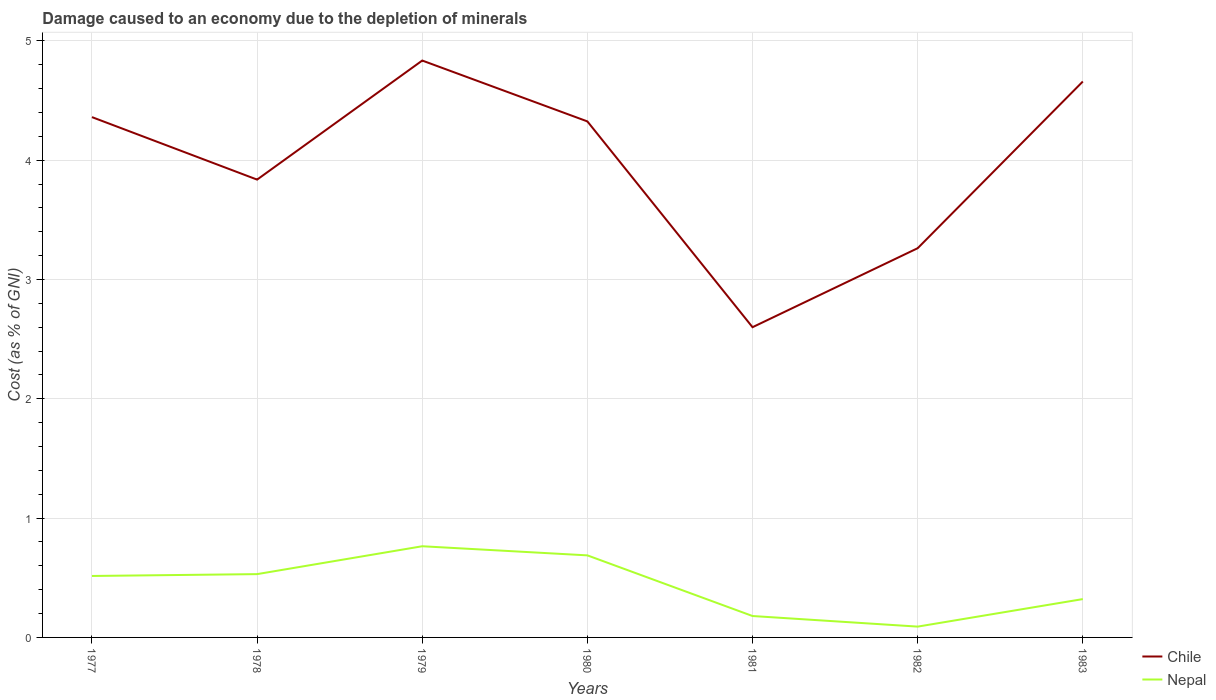How many different coloured lines are there?
Keep it short and to the point. 2. Is the number of lines equal to the number of legend labels?
Keep it short and to the point. Yes. Across all years, what is the maximum cost of damage caused due to the depletion of minerals in Chile?
Provide a short and direct response. 2.6. What is the total cost of damage caused due to the depletion of minerals in Nepal in the graph?
Ensure brevity in your answer.  -0.16. What is the difference between the highest and the second highest cost of damage caused due to the depletion of minerals in Nepal?
Your answer should be compact. 0.67. How many lines are there?
Keep it short and to the point. 2. What is the difference between two consecutive major ticks on the Y-axis?
Offer a terse response. 1. Are the values on the major ticks of Y-axis written in scientific E-notation?
Give a very brief answer. No. Where does the legend appear in the graph?
Keep it short and to the point. Bottom right. How many legend labels are there?
Offer a very short reply. 2. How are the legend labels stacked?
Offer a very short reply. Vertical. What is the title of the graph?
Offer a terse response. Damage caused to an economy due to the depletion of minerals. Does "Eritrea" appear as one of the legend labels in the graph?
Offer a very short reply. No. What is the label or title of the Y-axis?
Give a very brief answer. Cost (as % of GNI). What is the Cost (as % of GNI) of Chile in 1977?
Your response must be concise. 4.36. What is the Cost (as % of GNI) of Nepal in 1977?
Your answer should be compact. 0.52. What is the Cost (as % of GNI) of Chile in 1978?
Your answer should be very brief. 3.84. What is the Cost (as % of GNI) in Nepal in 1978?
Make the answer very short. 0.53. What is the Cost (as % of GNI) of Chile in 1979?
Keep it short and to the point. 4.83. What is the Cost (as % of GNI) in Nepal in 1979?
Offer a terse response. 0.76. What is the Cost (as % of GNI) of Chile in 1980?
Give a very brief answer. 4.32. What is the Cost (as % of GNI) in Nepal in 1980?
Provide a succinct answer. 0.69. What is the Cost (as % of GNI) in Chile in 1981?
Ensure brevity in your answer.  2.6. What is the Cost (as % of GNI) of Nepal in 1981?
Your answer should be compact. 0.18. What is the Cost (as % of GNI) in Chile in 1982?
Your answer should be very brief. 3.26. What is the Cost (as % of GNI) in Nepal in 1982?
Give a very brief answer. 0.09. What is the Cost (as % of GNI) in Chile in 1983?
Offer a very short reply. 4.66. What is the Cost (as % of GNI) of Nepal in 1983?
Offer a very short reply. 0.32. Across all years, what is the maximum Cost (as % of GNI) of Chile?
Offer a terse response. 4.83. Across all years, what is the maximum Cost (as % of GNI) of Nepal?
Your answer should be compact. 0.76. Across all years, what is the minimum Cost (as % of GNI) in Chile?
Your answer should be compact. 2.6. Across all years, what is the minimum Cost (as % of GNI) in Nepal?
Ensure brevity in your answer.  0.09. What is the total Cost (as % of GNI) of Chile in the graph?
Provide a succinct answer. 27.88. What is the total Cost (as % of GNI) in Nepal in the graph?
Keep it short and to the point. 3.09. What is the difference between the Cost (as % of GNI) of Chile in 1977 and that in 1978?
Your answer should be compact. 0.52. What is the difference between the Cost (as % of GNI) in Nepal in 1977 and that in 1978?
Give a very brief answer. -0.02. What is the difference between the Cost (as % of GNI) in Chile in 1977 and that in 1979?
Offer a terse response. -0.47. What is the difference between the Cost (as % of GNI) of Nepal in 1977 and that in 1979?
Your answer should be compact. -0.25. What is the difference between the Cost (as % of GNI) in Chile in 1977 and that in 1980?
Provide a short and direct response. 0.04. What is the difference between the Cost (as % of GNI) in Nepal in 1977 and that in 1980?
Your answer should be very brief. -0.17. What is the difference between the Cost (as % of GNI) in Chile in 1977 and that in 1981?
Keep it short and to the point. 1.76. What is the difference between the Cost (as % of GNI) of Nepal in 1977 and that in 1981?
Your response must be concise. 0.34. What is the difference between the Cost (as % of GNI) of Chile in 1977 and that in 1982?
Ensure brevity in your answer.  1.1. What is the difference between the Cost (as % of GNI) of Nepal in 1977 and that in 1982?
Make the answer very short. 0.42. What is the difference between the Cost (as % of GNI) in Chile in 1977 and that in 1983?
Your answer should be compact. -0.3. What is the difference between the Cost (as % of GNI) in Nepal in 1977 and that in 1983?
Your answer should be very brief. 0.19. What is the difference between the Cost (as % of GNI) in Chile in 1978 and that in 1979?
Offer a very short reply. -1. What is the difference between the Cost (as % of GNI) of Nepal in 1978 and that in 1979?
Ensure brevity in your answer.  -0.23. What is the difference between the Cost (as % of GNI) in Chile in 1978 and that in 1980?
Provide a short and direct response. -0.49. What is the difference between the Cost (as % of GNI) of Nepal in 1978 and that in 1980?
Provide a short and direct response. -0.16. What is the difference between the Cost (as % of GNI) in Chile in 1978 and that in 1981?
Make the answer very short. 1.24. What is the difference between the Cost (as % of GNI) of Nepal in 1978 and that in 1981?
Give a very brief answer. 0.35. What is the difference between the Cost (as % of GNI) of Chile in 1978 and that in 1982?
Ensure brevity in your answer.  0.57. What is the difference between the Cost (as % of GNI) of Nepal in 1978 and that in 1982?
Ensure brevity in your answer.  0.44. What is the difference between the Cost (as % of GNI) in Chile in 1978 and that in 1983?
Make the answer very short. -0.82. What is the difference between the Cost (as % of GNI) of Nepal in 1978 and that in 1983?
Ensure brevity in your answer.  0.21. What is the difference between the Cost (as % of GNI) of Chile in 1979 and that in 1980?
Give a very brief answer. 0.51. What is the difference between the Cost (as % of GNI) of Nepal in 1979 and that in 1980?
Keep it short and to the point. 0.08. What is the difference between the Cost (as % of GNI) in Chile in 1979 and that in 1981?
Provide a succinct answer. 2.23. What is the difference between the Cost (as % of GNI) in Nepal in 1979 and that in 1981?
Offer a very short reply. 0.58. What is the difference between the Cost (as % of GNI) of Chile in 1979 and that in 1982?
Your response must be concise. 1.57. What is the difference between the Cost (as % of GNI) in Nepal in 1979 and that in 1982?
Ensure brevity in your answer.  0.67. What is the difference between the Cost (as % of GNI) in Chile in 1979 and that in 1983?
Offer a very short reply. 0.18. What is the difference between the Cost (as % of GNI) in Nepal in 1979 and that in 1983?
Give a very brief answer. 0.44. What is the difference between the Cost (as % of GNI) of Chile in 1980 and that in 1981?
Give a very brief answer. 1.72. What is the difference between the Cost (as % of GNI) in Nepal in 1980 and that in 1981?
Give a very brief answer. 0.51. What is the difference between the Cost (as % of GNI) of Chile in 1980 and that in 1982?
Offer a terse response. 1.06. What is the difference between the Cost (as % of GNI) of Nepal in 1980 and that in 1982?
Provide a short and direct response. 0.6. What is the difference between the Cost (as % of GNI) in Chile in 1980 and that in 1983?
Give a very brief answer. -0.33. What is the difference between the Cost (as % of GNI) in Nepal in 1980 and that in 1983?
Ensure brevity in your answer.  0.37. What is the difference between the Cost (as % of GNI) in Chile in 1981 and that in 1982?
Provide a short and direct response. -0.66. What is the difference between the Cost (as % of GNI) of Nepal in 1981 and that in 1982?
Provide a succinct answer. 0.09. What is the difference between the Cost (as % of GNI) of Chile in 1981 and that in 1983?
Offer a terse response. -2.06. What is the difference between the Cost (as % of GNI) of Nepal in 1981 and that in 1983?
Your answer should be compact. -0.14. What is the difference between the Cost (as % of GNI) in Chile in 1982 and that in 1983?
Your answer should be very brief. -1.4. What is the difference between the Cost (as % of GNI) of Nepal in 1982 and that in 1983?
Keep it short and to the point. -0.23. What is the difference between the Cost (as % of GNI) in Chile in 1977 and the Cost (as % of GNI) in Nepal in 1978?
Ensure brevity in your answer.  3.83. What is the difference between the Cost (as % of GNI) in Chile in 1977 and the Cost (as % of GNI) in Nepal in 1979?
Your answer should be compact. 3.6. What is the difference between the Cost (as % of GNI) of Chile in 1977 and the Cost (as % of GNI) of Nepal in 1980?
Keep it short and to the point. 3.67. What is the difference between the Cost (as % of GNI) of Chile in 1977 and the Cost (as % of GNI) of Nepal in 1981?
Provide a succinct answer. 4.18. What is the difference between the Cost (as % of GNI) in Chile in 1977 and the Cost (as % of GNI) in Nepal in 1982?
Offer a very short reply. 4.27. What is the difference between the Cost (as % of GNI) of Chile in 1977 and the Cost (as % of GNI) of Nepal in 1983?
Your answer should be compact. 4.04. What is the difference between the Cost (as % of GNI) of Chile in 1978 and the Cost (as % of GNI) of Nepal in 1979?
Ensure brevity in your answer.  3.07. What is the difference between the Cost (as % of GNI) of Chile in 1978 and the Cost (as % of GNI) of Nepal in 1980?
Make the answer very short. 3.15. What is the difference between the Cost (as % of GNI) in Chile in 1978 and the Cost (as % of GNI) in Nepal in 1981?
Your answer should be compact. 3.66. What is the difference between the Cost (as % of GNI) in Chile in 1978 and the Cost (as % of GNI) in Nepal in 1982?
Provide a succinct answer. 3.75. What is the difference between the Cost (as % of GNI) in Chile in 1978 and the Cost (as % of GNI) in Nepal in 1983?
Offer a terse response. 3.52. What is the difference between the Cost (as % of GNI) of Chile in 1979 and the Cost (as % of GNI) of Nepal in 1980?
Make the answer very short. 4.15. What is the difference between the Cost (as % of GNI) of Chile in 1979 and the Cost (as % of GNI) of Nepal in 1981?
Keep it short and to the point. 4.66. What is the difference between the Cost (as % of GNI) in Chile in 1979 and the Cost (as % of GNI) in Nepal in 1982?
Ensure brevity in your answer.  4.74. What is the difference between the Cost (as % of GNI) in Chile in 1979 and the Cost (as % of GNI) in Nepal in 1983?
Provide a succinct answer. 4.51. What is the difference between the Cost (as % of GNI) in Chile in 1980 and the Cost (as % of GNI) in Nepal in 1981?
Give a very brief answer. 4.15. What is the difference between the Cost (as % of GNI) in Chile in 1980 and the Cost (as % of GNI) in Nepal in 1982?
Offer a terse response. 4.23. What is the difference between the Cost (as % of GNI) in Chile in 1980 and the Cost (as % of GNI) in Nepal in 1983?
Provide a succinct answer. 4. What is the difference between the Cost (as % of GNI) of Chile in 1981 and the Cost (as % of GNI) of Nepal in 1982?
Give a very brief answer. 2.51. What is the difference between the Cost (as % of GNI) of Chile in 1981 and the Cost (as % of GNI) of Nepal in 1983?
Your response must be concise. 2.28. What is the difference between the Cost (as % of GNI) in Chile in 1982 and the Cost (as % of GNI) in Nepal in 1983?
Offer a very short reply. 2.94. What is the average Cost (as % of GNI) in Chile per year?
Provide a succinct answer. 3.98. What is the average Cost (as % of GNI) of Nepal per year?
Provide a short and direct response. 0.44. In the year 1977, what is the difference between the Cost (as % of GNI) in Chile and Cost (as % of GNI) in Nepal?
Ensure brevity in your answer.  3.85. In the year 1978, what is the difference between the Cost (as % of GNI) of Chile and Cost (as % of GNI) of Nepal?
Your answer should be very brief. 3.31. In the year 1979, what is the difference between the Cost (as % of GNI) in Chile and Cost (as % of GNI) in Nepal?
Offer a very short reply. 4.07. In the year 1980, what is the difference between the Cost (as % of GNI) in Chile and Cost (as % of GNI) in Nepal?
Make the answer very short. 3.64. In the year 1981, what is the difference between the Cost (as % of GNI) of Chile and Cost (as % of GNI) of Nepal?
Provide a succinct answer. 2.42. In the year 1982, what is the difference between the Cost (as % of GNI) of Chile and Cost (as % of GNI) of Nepal?
Your answer should be compact. 3.17. In the year 1983, what is the difference between the Cost (as % of GNI) in Chile and Cost (as % of GNI) in Nepal?
Your answer should be compact. 4.34. What is the ratio of the Cost (as % of GNI) of Chile in 1977 to that in 1978?
Your answer should be very brief. 1.14. What is the ratio of the Cost (as % of GNI) in Chile in 1977 to that in 1979?
Provide a succinct answer. 0.9. What is the ratio of the Cost (as % of GNI) of Nepal in 1977 to that in 1979?
Make the answer very short. 0.67. What is the ratio of the Cost (as % of GNI) of Chile in 1977 to that in 1980?
Make the answer very short. 1.01. What is the ratio of the Cost (as % of GNI) of Nepal in 1977 to that in 1980?
Give a very brief answer. 0.75. What is the ratio of the Cost (as % of GNI) in Chile in 1977 to that in 1981?
Offer a terse response. 1.68. What is the ratio of the Cost (as % of GNI) of Nepal in 1977 to that in 1981?
Give a very brief answer. 2.87. What is the ratio of the Cost (as % of GNI) of Chile in 1977 to that in 1982?
Your answer should be compact. 1.34. What is the ratio of the Cost (as % of GNI) in Nepal in 1977 to that in 1982?
Provide a succinct answer. 5.68. What is the ratio of the Cost (as % of GNI) in Chile in 1977 to that in 1983?
Give a very brief answer. 0.94. What is the ratio of the Cost (as % of GNI) in Nepal in 1977 to that in 1983?
Offer a terse response. 1.6. What is the ratio of the Cost (as % of GNI) in Chile in 1978 to that in 1979?
Your answer should be very brief. 0.79. What is the ratio of the Cost (as % of GNI) in Nepal in 1978 to that in 1979?
Make the answer very short. 0.69. What is the ratio of the Cost (as % of GNI) in Chile in 1978 to that in 1980?
Your answer should be very brief. 0.89. What is the ratio of the Cost (as % of GNI) in Nepal in 1978 to that in 1980?
Your response must be concise. 0.77. What is the ratio of the Cost (as % of GNI) in Chile in 1978 to that in 1981?
Make the answer very short. 1.48. What is the ratio of the Cost (as % of GNI) in Nepal in 1978 to that in 1981?
Give a very brief answer. 2.96. What is the ratio of the Cost (as % of GNI) in Chile in 1978 to that in 1982?
Ensure brevity in your answer.  1.18. What is the ratio of the Cost (as % of GNI) of Nepal in 1978 to that in 1982?
Your response must be concise. 5.85. What is the ratio of the Cost (as % of GNI) of Chile in 1978 to that in 1983?
Offer a very short reply. 0.82. What is the ratio of the Cost (as % of GNI) in Nepal in 1978 to that in 1983?
Ensure brevity in your answer.  1.65. What is the ratio of the Cost (as % of GNI) of Chile in 1979 to that in 1980?
Offer a very short reply. 1.12. What is the ratio of the Cost (as % of GNI) of Chile in 1979 to that in 1981?
Provide a short and direct response. 1.86. What is the ratio of the Cost (as % of GNI) in Nepal in 1979 to that in 1981?
Provide a short and direct response. 4.26. What is the ratio of the Cost (as % of GNI) in Chile in 1979 to that in 1982?
Ensure brevity in your answer.  1.48. What is the ratio of the Cost (as % of GNI) of Nepal in 1979 to that in 1982?
Your answer should be very brief. 8.43. What is the ratio of the Cost (as % of GNI) in Chile in 1979 to that in 1983?
Provide a succinct answer. 1.04. What is the ratio of the Cost (as % of GNI) in Nepal in 1979 to that in 1983?
Your answer should be compact. 2.38. What is the ratio of the Cost (as % of GNI) of Chile in 1980 to that in 1981?
Your response must be concise. 1.66. What is the ratio of the Cost (as % of GNI) of Nepal in 1980 to that in 1981?
Provide a succinct answer. 3.83. What is the ratio of the Cost (as % of GNI) of Chile in 1980 to that in 1982?
Your answer should be very brief. 1.33. What is the ratio of the Cost (as % of GNI) in Nepal in 1980 to that in 1982?
Keep it short and to the point. 7.59. What is the ratio of the Cost (as % of GNI) in Chile in 1980 to that in 1983?
Offer a terse response. 0.93. What is the ratio of the Cost (as % of GNI) of Nepal in 1980 to that in 1983?
Ensure brevity in your answer.  2.14. What is the ratio of the Cost (as % of GNI) in Chile in 1981 to that in 1982?
Your answer should be very brief. 0.8. What is the ratio of the Cost (as % of GNI) of Nepal in 1981 to that in 1982?
Keep it short and to the point. 1.98. What is the ratio of the Cost (as % of GNI) of Chile in 1981 to that in 1983?
Make the answer very short. 0.56. What is the ratio of the Cost (as % of GNI) of Nepal in 1981 to that in 1983?
Your response must be concise. 0.56. What is the ratio of the Cost (as % of GNI) of Chile in 1982 to that in 1983?
Your response must be concise. 0.7. What is the ratio of the Cost (as % of GNI) in Nepal in 1982 to that in 1983?
Offer a very short reply. 0.28. What is the difference between the highest and the second highest Cost (as % of GNI) of Chile?
Offer a very short reply. 0.18. What is the difference between the highest and the second highest Cost (as % of GNI) of Nepal?
Offer a very short reply. 0.08. What is the difference between the highest and the lowest Cost (as % of GNI) in Chile?
Your response must be concise. 2.23. What is the difference between the highest and the lowest Cost (as % of GNI) of Nepal?
Make the answer very short. 0.67. 